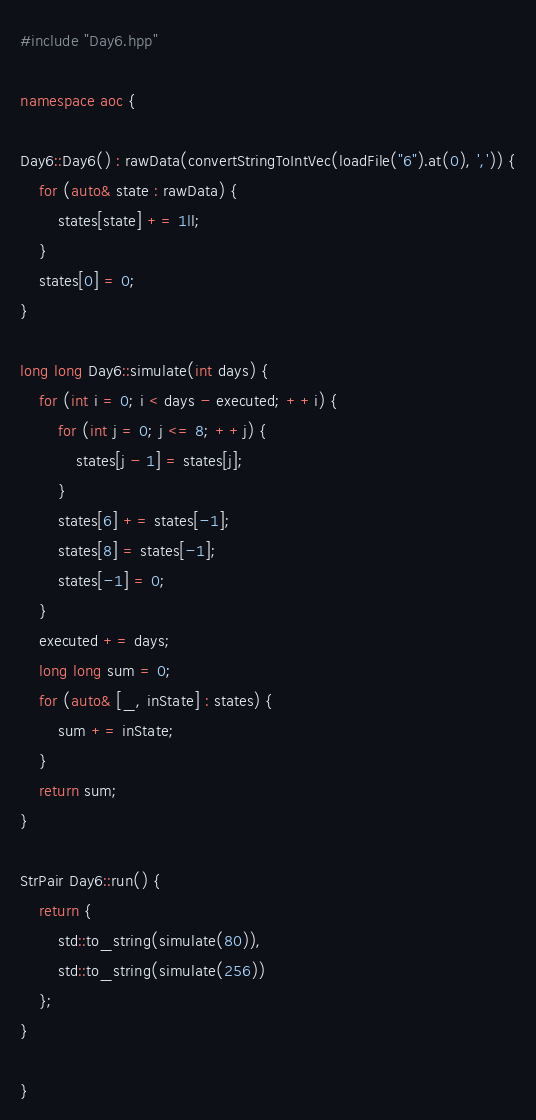Convert code to text. <code><loc_0><loc_0><loc_500><loc_500><_C++_>#include "Day6.hpp"

namespace aoc {

Day6::Day6() : rawData(convertStringToIntVec(loadFile("6").at(0), ',')) {
    for (auto& state : rawData) {
        states[state] += 1ll;
    }
    states[0] = 0;
}

long long Day6::simulate(int days) {
    for (int i = 0; i < days - executed; ++i) {
        for (int j = 0; j <= 8; ++j) {
            states[j - 1] = states[j];
        }
        states[6] += states[-1];
        states[8] = states[-1];
        states[-1] = 0;
    }
    executed += days;
    long long sum = 0;
    for (auto& [_, inState] : states) {
        sum += inState;
    }
    return sum;
}

StrPair Day6::run() {
    return {
        std::to_string(simulate(80)),
        std::to_string(simulate(256))
    };
}

}
</code> 